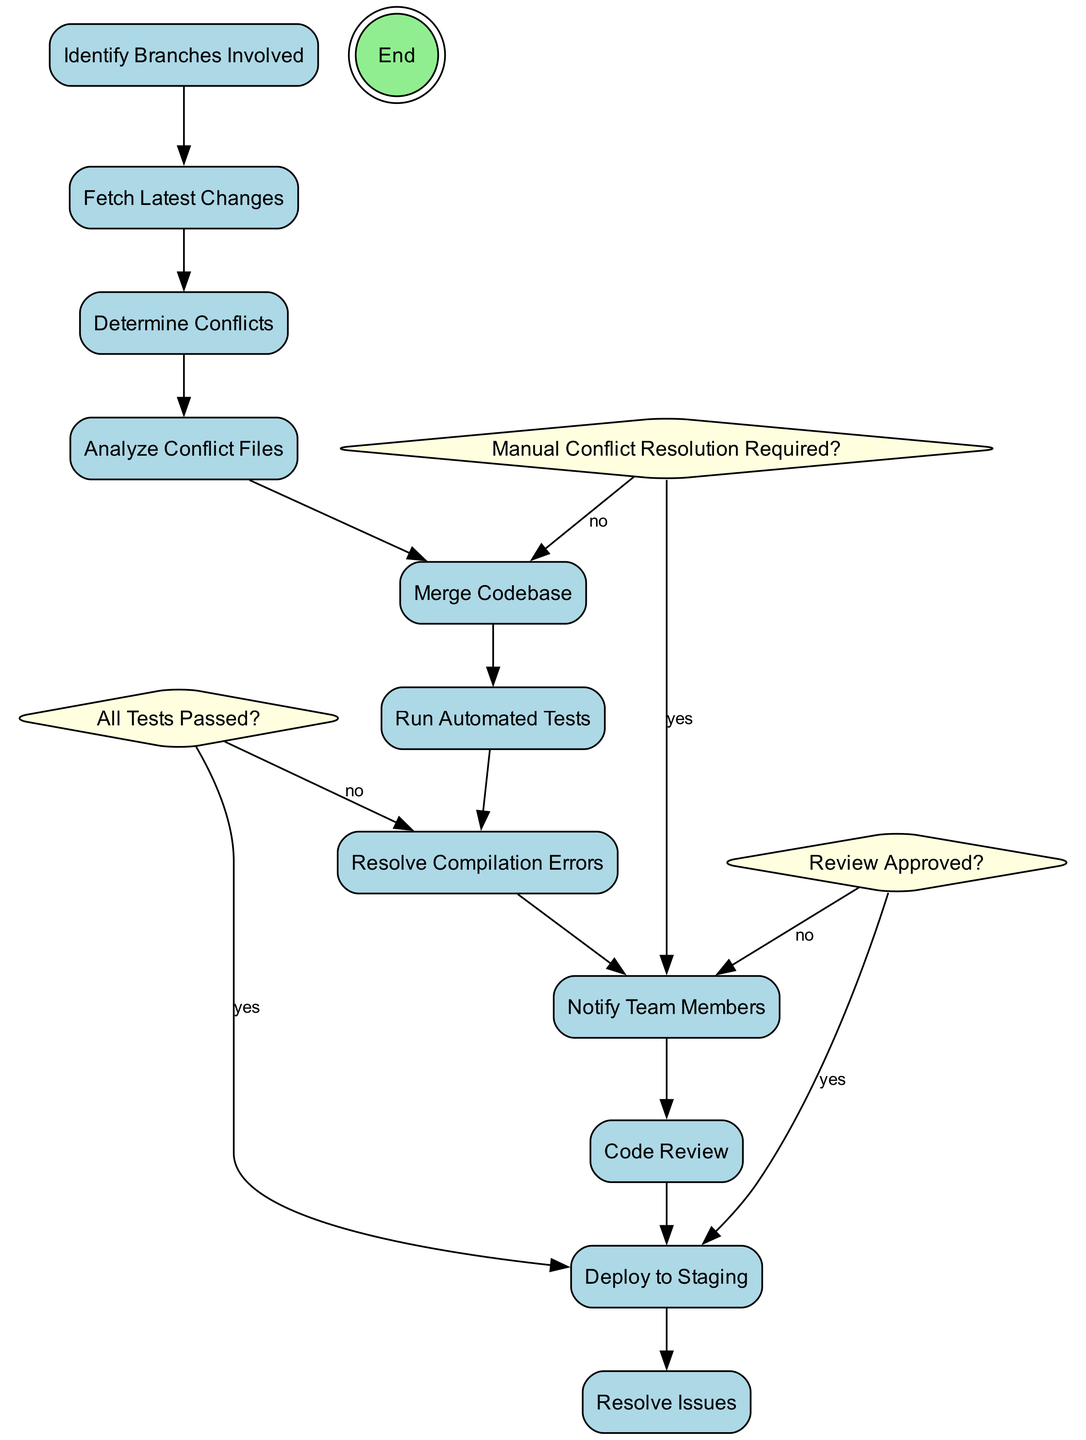What is the first action in the diagram? The diagram starts with the action node "Identify Branches Involved" which indicates the first step in resolving integration conflicts.
Answer: Identify Branches Involved How many decision nodes are present in the diagram? By counting the different shaped nodes designated as diamonds, there are three decision nodes: "Manual Conflict Resolution Required?", "All Tests Passed?", and "Review Approved?".
Answer: 3 What does the decision "Manual Conflict Resolution Required?" lead to if the answer is "yes"? If the answer is "yes," it leads to the action node "Notify Team Members," indicating the necessary communication to the team before proceeding further.
Answer: Notify Team Members What happens if the answer to "All Tests Passed?" is "no"? If the answer is "no," the diagram shows a path directing to the action node "Resolve Compilation Errors," indicating that unresolved issues need to be addressed.
Answer: Resolve Compilation Errors What action follows after "Analyze Conflict Files"? After "Analyze Conflict Files," the next action in sequence is "Merge Codebase," indicating that once analysis is completed, the merging of code can proceed.
Answer: Merge Codebase What is the final action before reaching the end of the diagram? The final action before reaching the end node is "Deploy to Staging," which suggests that once all previous steps are successfully completed, deployment occurs.
Answer: Deploy to Staging What is the consequence of "Review Approved?" being "no"? If "Review Approved?" is "no," it leads back to "Notify Team Members," meaning the team is informed about the need for further review before moving on.
Answer: Notify Team Members What is the last action taken right before the end node? The last action taken right before reaching the end node is "Deploy to Staging," which signifies the completion of the integration process.
Answer: Deploy to Staging 